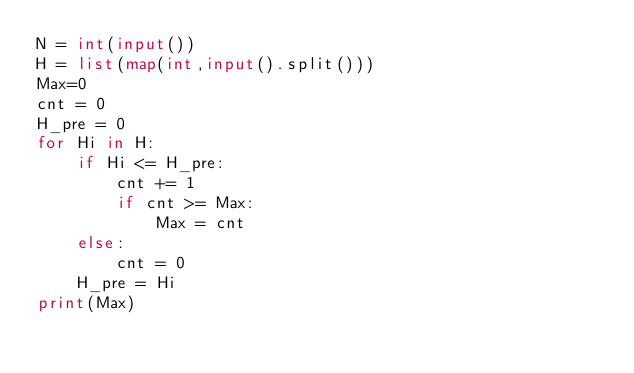<code> <loc_0><loc_0><loc_500><loc_500><_Python_>N = int(input())
H = list(map(int,input().split()))
Max=0
cnt = 0
H_pre = 0
for Hi in H:
    if Hi <= H_pre:
        cnt += 1
        if cnt >= Max:
            Max = cnt
    else:
        cnt = 0
    H_pre = Hi
print(Max)</code> 